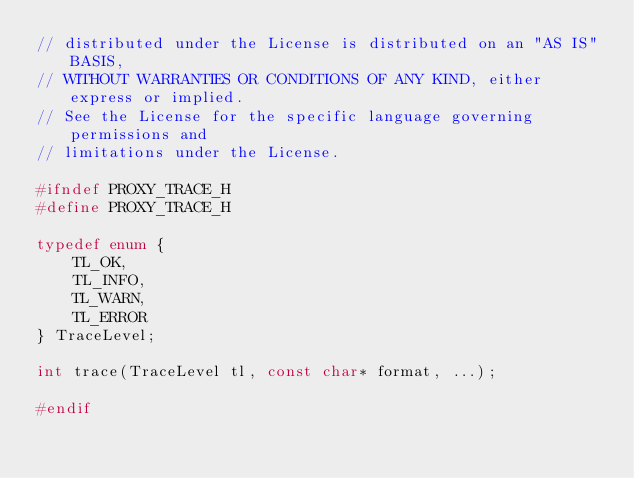Convert code to text. <code><loc_0><loc_0><loc_500><loc_500><_C_>// distributed under the License is distributed on an "AS IS" BASIS,
// WITHOUT WARRANTIES OR CONDITIONS OF ANY KIND, either express or implied.
// See the License for the specific language governing permissions and
// limitations under the License.

#ifndef PROXY_TRACE_H
#define PROXY_TRACE_H

typedef enum {
    TL_OK,
    TL_INFO,
    TL_WARN,
    TL_ERROR
} TraceLevel;

int trace(TraceLevel tl, const char* format, ...);

#endif
</code> 